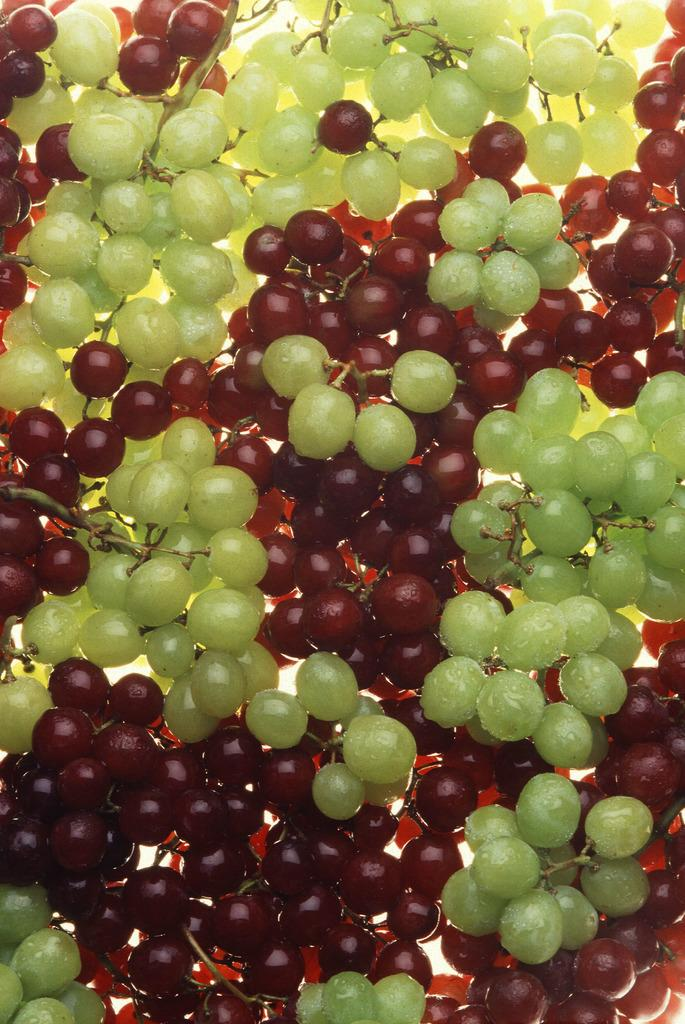What type of fruit is present in the image? There are green and red grapes in the image. What color are the green grapes? The green grapes are green. What color are the red grapes? The red grapes are red. What surface are the grapes placed on? The grapes are placed on a white surface. What type of bait is used for fishing in the image? There is no fishing or bait present in the image; it features green and red grapes on a white surface. 